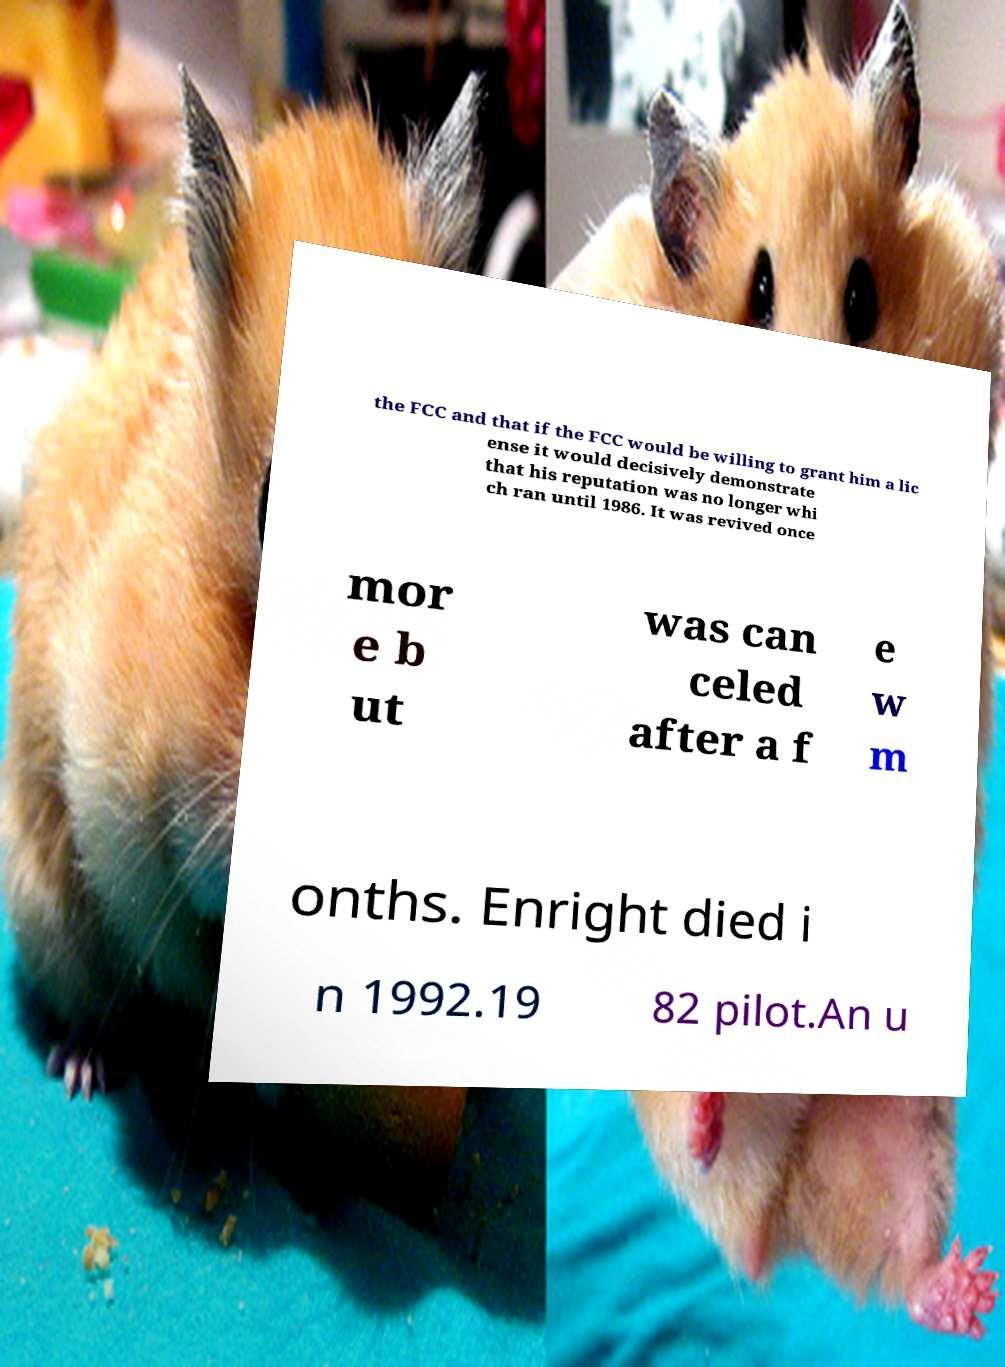Please identify and transcribe the text found in this image. the FCC and that if the FCC would be willing to grant him a lic ense it would decisively demonstrate that his reputation was no longer whi ch ran until 1986. It was revived once mor e b ut was can celed after a f e w m onths. Enright died i n 1992.19 82 pilot.An u 